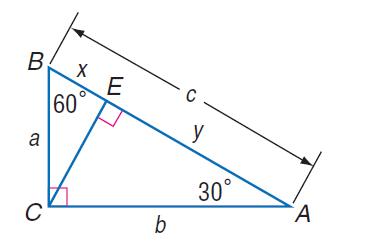Answer the mathemtical geometry problem and directly provide the correct option letter.
Question: If x = 7 \sqrt { 3 }, find y.
Choices: A: 7 B: 7 \sqrt { 3 } C: 21 \sqrt { 3 } D: 63 C 